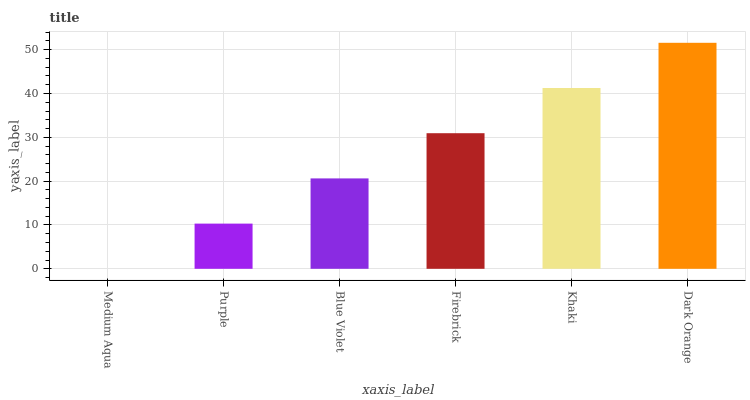Is Medium Aqua the minimum?
Answer yes or no. Yes. Is Dark Orange the maximum?
Answer yes or no. Yes. Is Purple the minimum?
Answer yes or no. No. Is Purple the maximum?
Answer yes or no. No. Is Purple greater than Medium Aqua?
Answer yes or no. Yes. Is Medium Aqua less than Purple?
Answer yes or no. Yes. Is Medium Aqua greater than Purple?
Answer yes or no. No. Is Purple less than Medium Aqua?
Answer yes or no. No. Is Firebrick the high median?
Answer yes or no. Yes. Is Blue Violet the low median?
Answer yes or no. Yes. Is Dark Orange the high median?
Answer yes or no. No. Is Firebrick the low median?
Answer yes or no. No. 